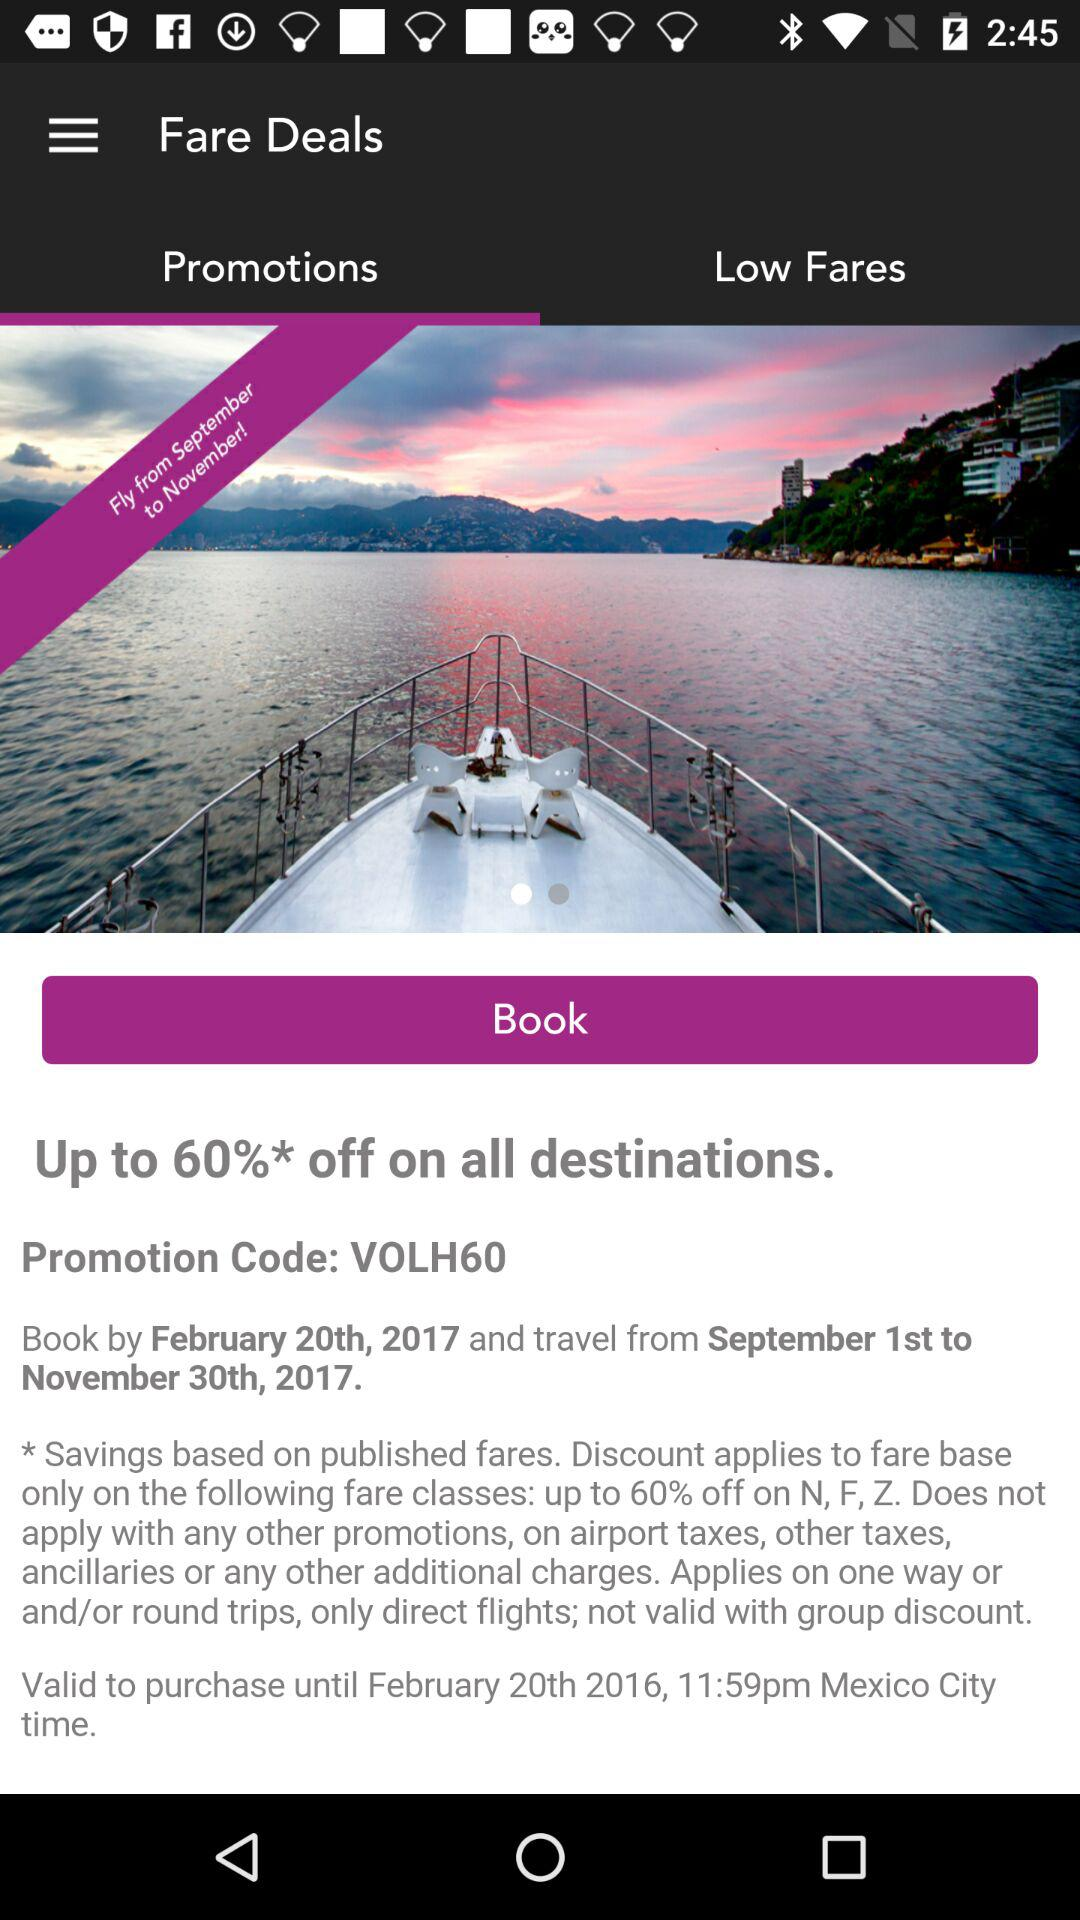What is the last date for bookings? The last date for booking is February 20, 2017. 